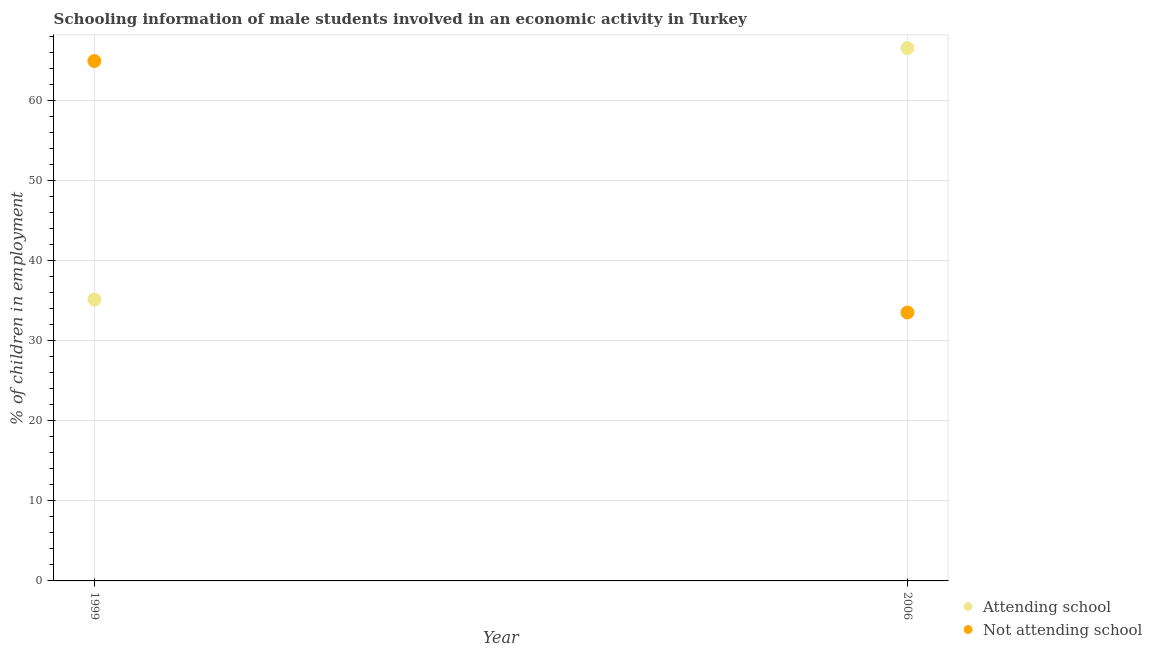How many different coloured dotlines are there?
Provide a short and direct response. 2. What is the percentage of employed males who are not attending school in 1999?
Offer a terse response. 64.89. Across all years, what is the maximum percentage of employed males who are attending school?
Your answer should be compact. 66.5. Across all years, what is the minimum percentage of employed males who are not attending school?
Offer a terse response. 33.5. In which year was the percentage of employed males who are not attending school minimum?
Your response must be concise. 2006. What is the total percentage of employed males who are not attending school in the graph?
Give a very brief answer. 98.39. What is the difference between the percentage of employed males who are not attending school in 1999 and that in 2006?
Your answer should be very brief. 31.39. What is the difference between the percentage of employed males who are not attending school in 2006 and the percentage of employed males who are attending school in 1999?
Your answer should be very brief. -1.61. What is the average percentage of employed males who are attending school per year?
Provide a succinct answer. 50.81. In how many years, is the percentage of employed males who are not attending school greater than 8 %?
Offer a very short reply. 2. What is the ratio of the percentage of employed males who are attending school in 1999 to that in 2006?
Your answer should be very brief. 0.53. In how many years, is the percentage of employed males who are attending school greater than the average percentage of employed males who are attending school taken over all years?
Your response must be concise. 1. Is the percentage of employed males who are not attending school strictly greater than the percentage of employed males who are attending school over the years?
Offer a terse response. No. How many dotlines are there?
Ensure brevity in your answer.  2. What is the difference between two consecutive major ticks on the Y-axis?
Keep it short and to the point. 10. Does the graph contain grids?
Give a very brief answer. Yes. What is the title of the graph?
Keep it short and to the point. Schooling information of male students involved in an economic activity in Turkey. Does "Public credit registry" appear as one of the legend labels in the graph?
Your response must be concise. No. What is the label or title of the X-axis?
Provide a succinct answer. Year. What is the label or title of the Y-axis?
Your answer should be compact. % of children in employment. What is the % of children in employment of Attending school in 1999?
Provide a succinct answer. 35.11. What is the % of children in employment in Not attending school in 1999?
Offer a terse response. 64.89. What is the % of children in employment in Attending school in 2006?
Offer a very short reply. 66.5. What is the % of children in employment of Not attending school in 2006?
Give a very brief answer. 33.5. Across all years, what is the maximum % of children in employment of Attending school?
Your answer should be very brief. 66.5. Across all years, what is the maximum % of children in employment in Not attending school?
Keep it short and to the point. 64.89. Across all years, what is the minimum % of children in employment of Attending school?
Your answer should be compact. 35.11. Across all years, what is the minimum % of children in employment in Not attending school?
Provide a succinct answer. 33.5. What is the total % of children in employment in Attending school in the graph?
Offer a terse response. 101.61. What is the total % of children in employment of Not attending school in the graph?
Your response must be concise. 98.39. What is the difference between the % of children in employment of Attending school in 1999 and that in 2006?
Give a very brief answer. -31.39. What is the difference between the % of children in employment of Not attending school in 1999 and that in 2006?
Ensure brevity in your answer.  31.39. What is the difference between the % of children in employment of Attending school in 1999 and the % of children in employment of Not attending school in 2006?
Ensure brevity in your answer.  1.61. What is the average % of children in employment of Attending school per year?
Ensure brevity in your answer.  50.81. What is the average % of children in employment of Not attending school per year?
Offer a terse response. 49.19. In the year 1999, what is the difference between the % of children in employment in Attending school and % of children in employment in Not attending school?
Your response must be concise. -29.77. What is the ratio of the % of children in employment in Attending school in 1999 to that in 2006?
Provide a succinct answer. 0.53. What is the ratio of the % of children in employment of Not attending school in 1999 to that in 2006?
Offer a very short reply. 1.94. What is the difference between the highest and the second highest % of children in employment of Attending school?
Make the answer very short. 31.39. What is the difference between the highest and the second highest % of children in employment in Not attending school?
Your response must be concise. 31.39. What is the difference between the highest and the lowest % of children in employment in Attending school?
Your answer should be compact. 31.39. What is the difference between the highest and the lowest % of children in employment in Not attending school?
Offer a terse response. 31.39. 